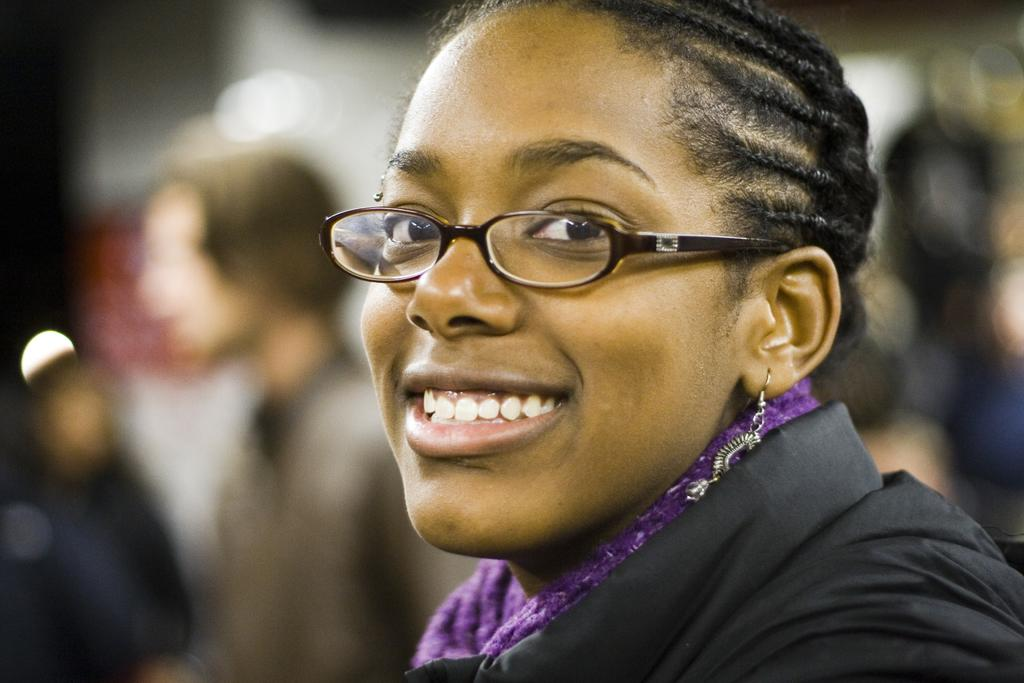Who is present in the image? There is a woman in the image. What is the woman doing in the image? The woman is smiling in the image. What accessory is the woman wearing? The woman is wearing spectacles in the image. Can you describe the background of the image? The background of the image is blurred. What type of worm can be seen crawling on the linen in the image? There is no worm or linen present in the image; it features a woman smiling and wearing spectacles with a blurred background. 